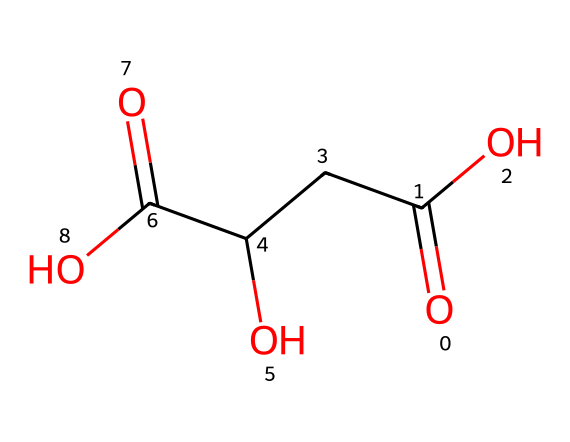how many carbon atoms are in the chemical structure? By analyzing the SMILES representation, we count the number of carbon (C) symbols present in the structure. There are three carbon atoms indicated by the presence of three 'C' in the chain connecting the two carboxylic acid groups.
Answer: three what functional groups are present in this compound? The SMILES representation shows two carboxylic acid groups (indicated by 'C(=O)O') and one alcohol group (indicated by 'CC(O)'). Hence, we have carboxylic acids and an alcohol as functional groups.
Answer: carboxylic acids and alcohol what is the total number of oxygen atoms present in this compound? Counting the 'O' in the SMILES representation, there are four oxygen atoms visible: two from the carboxylic acid groups and one from the alcohol group.
Answer: four which type of organic acid is represented by this compound? The presence of the two carboxylic acid functional groups (C(=O)O) suggests that this molecule is a dicarboxylic acid, specifically identified within malic acid.
Answer: dicarboxylic acid how does the presence of the alcohol group affect the properties of malic acid? The alcohol group (indicated by 'C(O)') enhances the solubility of malic acid in water and contributes to its acidity. This interaction can affect its flavor profile in food applications.
Answer: enhances solubility and acidity is this compound naturally occurring in food sources? Malic acid is commonly found in various fruits, particularly in apples, confirming its presence in food sources.
Answer: yes how many stereogenic centers does malic acid have? Analyzing the structure, we find one stereogenic center at the carbon connected to the alcohol group. This center allows for stereoisomerism in malic acid.
Answer: one 